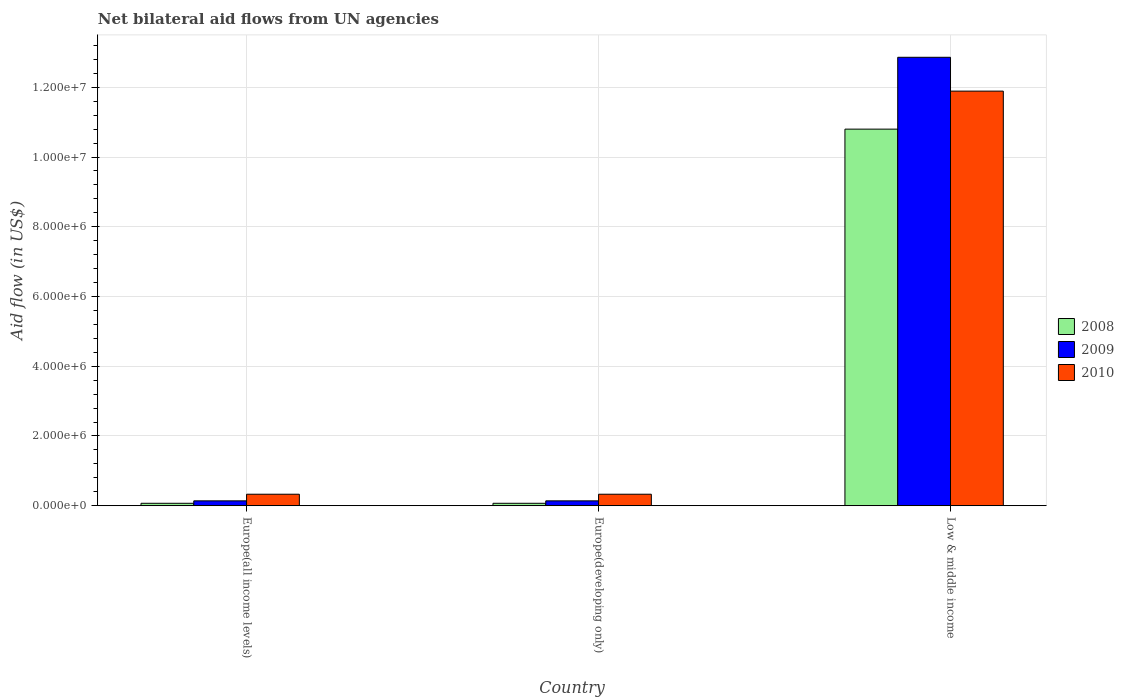How many bars are there on the 2nd tick from the right?
Your answer should be very brief. 3. What is the label of the 3rd group of bars from the left?
Make the answer very short. Low & middle income. In how many cases, is the number of bars for a given country not equal to the number of legend labels?
Ensure brevity in your answer.  0. What is the net bilateral aid flow in 2008 in Europe(developing only)?
Your answer should be very brief. 7.00e+04. Across all countries, what is the maximum net bilateral aid flow in 2008?
Make the answer very short. 1.08e+07. In which country was the net bilateral aid flow in 2008 maximum?
Your answer should be compact. Low & middle income. In which country was the net bilateral aid flow in 2010 minimum?
Your response must be concise. Europe(all income levels). What is the total net bilateral aid flow in 2009 in the graph?
Give a very brief answer. 1.31e+07. What is the difference between the net bilateral aid flow in 2009 in Europe(developing only) and that in Low & middle income?
Ensure brevity in your answer.  -1.27e+07. What is the difference between the net bilateral aid flow in 2009 in Low & middle income and the net bilateral aid flow in 2010 in Europe(all income levels)?
Provide a short and direct response. 1.25e+07. What is the average net bilateral aid flow in 2009 per country?
Keep it short and to the point. 4.38e+06. What is the ratio of the net bilateral aid flow in 2010 in Europe(developing only) to that in Low & middle income?
Your answer should be compact. 0.03. Is the net bilateral aid flow in 2010 in Europe(developing only) less than that in Low & middle income?
Make the answer very short. Yes. Is the difference between the net bilateral aid flow in 2010 in Europe(all income levels) and Europe(developing only) greater than the difference between the net bilateral aid flow in 2008 in Europe(all income levels) and Europe(developing only)?
Provide a succinct answer. No. What is the difference between the highest and the second highest net bilateral aid flow in 2010?
Keep it short and to the point. 1.16e+07. What is the difference between the highest and the lowest net bilateral aid flow in 2010?
Your answer should be compact. 1.16e+07. In how many countries, is the net bilateral aid flow in 2008 greater than the average net bilateral aid flow in 2008 taken over all countries?
Your answer should be compact. 1. Is the sum of the net bilateral aid flow in 2009 in Europe(all income levels) and Low & middle income greater than the maximum net bilateral aid flow in 2010 across all countries?
Your answer should be very brief. Yes. What does the 3rd bar from the left in Europe(all income levels) represents?
Provide a succinct answer. 2010. Does the graph contain any zero values?
Keep it short and to the point. No. How many legend labels are there?
Give a very brief answer. 3. How are the legend labels stacked?
Ensure brevity in your answer.  Vertical. What is the title of the graph?
Provide a short and direct response. Net bilateral aid flows from UN agencies. Does "2003" appear as one of the legend labels in the graph?
Your answer should be compact. No. What is the label or title of the Y-axis?
Your answer should be compact. Aid flow (in US$). What is the Aid flow (in US$) of 2008 in Europe(all income levels)?
Your response must be concise. 7.00e+04. What is the Aid flow (in US$) in 2008 in Europe(developing only)?
Offer a very short reply. 7.00e+04. What is the Aid flow (in US$) in 2009 in Europe(developing only)?
Offer a very short reply. 1.40e+05. What is the Aid flow (in US$) in 2008 in Low & middle income?
Make the answer very short. 1.08e+07. What is the Aid flow (in US$) in 2009 in Low & middle income?
Ensure brevity in your answer.  1.29e+07. What is the Aid flow (in US$) in 2010 in Low & middle income?
Give a very brief answer. 1.19e+07. Across all countries, what is the maximum Aid flow (in US$) of 2008?
Offer a very short reply. 1.08e+07. Across all countries, what is the maximum Aid flow (in US$) in 2009?
Provide a succinct answer. 1.29e+07. Across all countries, what is the maximum Aid flow (in US$) in 2010?
Your response must be concise. 1.19e+07. What is the total Aid flow (in US$) in 2008 in the graph?
Ensure brevity in your answer.  1.09e+07. What is the total Aid flow (in US$) in 2009 in the graph?
Offer a very short reply. 1.31e+07. What is the total Aid flow (in US$) of 2010 in the graph?
Offer a terse response. 1.26e+07. What is the difference between the Aid flow (in US$) in 2008 in Europe(all income levels) and that in Low & middle income?
Give a very brief answer. -1.07e+07. What is the difference between the Aid flow (in US$) of 2009 in Europe(all income levels) and that in Low & middle income?
Keep it short and to the point. -1.27e+07. What is the difference between the Aid flow (in US$) of 2010 in Europe(all income levels) and that in Low & middle income?
Ensure brevity in your answer.  -1.16e+07. What is the difference between the Aid flow (in US$) in 2008 in Europe(developing only) and that in Low & middle income?
Provide a short and direct response. -1.07e+07. What is the difference between the Aid flow (in US$) in 2009 in Europe(developing only) and that in Low & middle income?
Your answer should be compact. -1.27e+07. What is the difference between the Aid flow (in US$) of 2010 in Europe(developing only) and that in Low & middle income?
Offer a very short reply. -1.16e+07. What is the difference between the Aid flow (in US$) of 2008 in Europe(all income levels) and the Aid flow (in US$) of 2009 in Europe(developing only)?
Provide a succinct answer. -7.00e+04. What is the difference between the Aid flow (in US$) in 2008 in Europe(all income levels) and the Aid flow (in US$) in 2010 in Europe(developing only)?
Offer a very short reply. -2.60e+05. What is the difference between the Aid flow (in US$) of 2009 in Europe(all income levels) and the Aid flow (in US$) of 2010 in Europe(developing only)?
Make the answer very short. -1.90e+05. What is the difference between the Aid flow (in US$) in 2008 in Europe(all income levels) and the Aid flow (in US$) in 2009 in Low & middle income?
Provide a succinct answer. -1.28e+07. What is the difference between the Aid flow (in US$) in 2008 in Europe(all income levels) and the Aid flow (in US$) in 2010 in Low & middle income?
Your answer should be compact. -1.18e+07. What is the difference between the Aid flow (in US$) of 2009 in Europe(all income levels) and the Aid flow (in US$) of 2010 in Low & middle income?
Provide a short and direct response. -1.18e+07. What is the difference between the Aid flow (in US$) of 2008 in Europe(developing only) and the Aid flow (in US$) of 2009 in Low & middle income?
Your answer should be very brief. -1.28e+07. What is the difference between the Aid flow (in US$) of 2008 in Europe(developing only) and the Aid flow (in US$) of 2010 in Low & middle income?
Ensure brevity in your answer.  -1.18e+07. What is the difference between the Aid flow (in US$) in 2009 in Europe(developing only) and the Aid flow (in US$) in 2010 in Low & middle income?
Your response must be concise. -1.18e+07. What is the average Aid flow (in US$) in 2008 per country?
Make the answer very short. 3.65e+06. What is the average Aid flow (in US$) in 2009 per country?
Your answer should be very brief. 4.38e+06. What is the average Aid flow (in US$) in 2010 per country?
Offer a very short reply. 4.18e+06. What is the difference between the Aid flow (in US$) of 2008 and Aid flow (in US$) of 2009 in Europe(all income levels)?
Offer a terse response. -7.00e+04. What is the difference between the Aid flow (in US$) of 2008 and Aid flow (in US$) of 2010 in Europe(all income levels)?
Your response must be concise. -2.60e+05. What is the difference between the Aid flow (in US$) in 2009 and Aid flow (in US$) in 2010 in Europe(all income levels)?
Offer a terse response. -1.90e+05. What is the difference between the Aid flow (in US$) of 2008 and Aid flow (in US$) of 2009 in Europe(developing only)?
Your answer should be very brief. -7.00e+04. What is the difference between the Aid flow (in US$) in 2008 and Aid flow (in US$) in 2009 in Low & middle income?
Your answer should be very brief. -2.06e+06. What is the difference between the Aid flow (in US$) in 2008 and Aid flow (in US$) in 2010 in Low & middle income?
Ensure brevity in your answer.  -1.09e+06. What is the difference between the Aid flow (in US$) in 2009 and Aid flow (in US$) in 2010 in Low & middle income?
Offer a terse response. 9.70e+05. What is the ratio of the Aid flow (in US$) in 2008 in Europe(all income levels) to that in Low & middle income?
Offer a very short reply. 0.01. What is the ratio of the Aid flow (in US$) of 2009 in Europe(all income levels) to that in Low & middle income?
Your response must be concise. 0.01. What is the ratio of the Aid flow (in US$) in 2010 in Europe(all income levels) to that in Low & middle income?
Offer a very short reply. 0.03. What is the ratio of the Aid flow (in US$) of 2008 in Europe(developing only) to that in Low & middle income?
Make the answer very short. 0.01. What is the ratio of the Aid flow (in US$) of 2009 in Europe(developing only) to that in Low & middle income?
Your response must be concise. 0.01. What is the ratio of the Aid flow (in US$) in 2010 in Europe(developing only) to that in Low & middle income?
Provide a succinct answer. 0.03. What is the difference between the highest and the second highest Aid flow (in US$) in 2008?
Ensure brevity in your answer.  1.07e+07. What is the difference between the highest and the second highest Aid flow (in US$) of 2009?
Provide a short and direct response. 1.27e+07. What is the difference between the highest and the second highest Aid flow (in US$) in 2010?
Provide a short and direct response. 1.16e+07. What is the difference between the highest and the lowest Aid flow (in US$) in 2008?
Your answer should be very brief. 1.07e+07. What is the difference between the highest and the lowest Aid flow (in US$) of 2009?
Your answer should be compact. 1.27e+07. What is the difference between the highest and the lowest Aid flow (in US$) of 2010?
Offer a very short reply. 1.16e+07. 